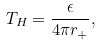Convert formula to latex. <formula><loc_0><loc_0><loc_500><loc_500>T _ { H } = \frac { \epsilon } { 4 \pi r _ { + } } ,</formula> 